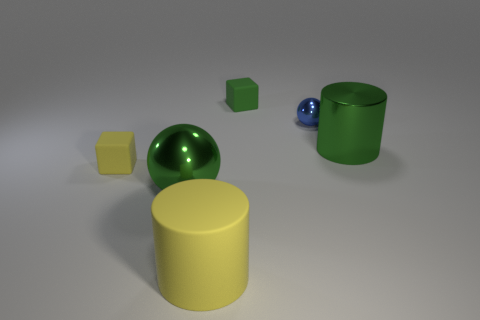Can you describe the difference in size between the objects that appear to be the same shape? Certainly! The two spherical objects differ in size with one being significantly smaller, resembling a marble, while the larger one could be likened to a bowling ball. The cubes also show a size variation where one is distinctly smaller, similar in scale to a dice, as opposed to its larger counterpart which could resemble a toy block. 